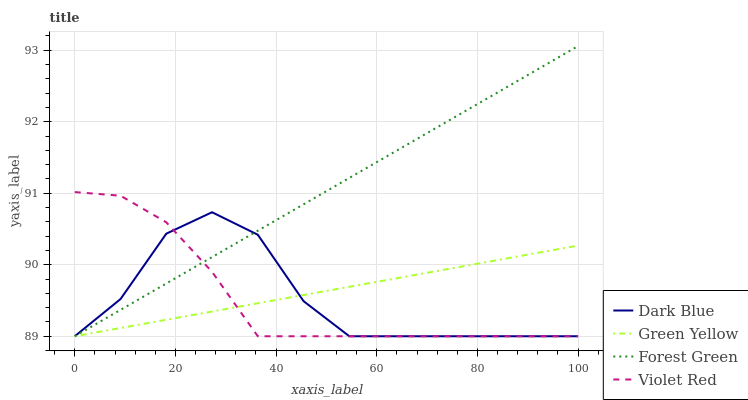Does Violet Red have the minimum area under the curve?
Answer yes or no. Yes. Does Forest Green have the maximum area under the curve?
Answer yes or no. Yes. Does Green Yellow have the minimum area under the curve?
Answer yes or no. No. Does Green Yellow have the maximum area under the curve?
Answer yes or no. No. Is Forest Green the smoothest?
Answer yes or no. Yes. Is Dark Blue the roughest?
Answer yes or no. Yes. Is Green Yellow the smoothest?
Answer yes or no. No. Is Green Yellow the roughest?
Answer yes or no. No. Does Dark Blue have the lowest value?
Answer yes or no. Yes. Does Forest Green have the highest value?
Answer yes or no. Yes. Does Green Yellow have the highest value?
Answer yes or no. No. Does Violet Red intersect Dark Blue?
Answer yes or no. Yes. Is Violet Red less than Dark Blue?
Answer yes or no. No. Is Violet Red greater than Dark Blue?
Answer yes or no. No. 